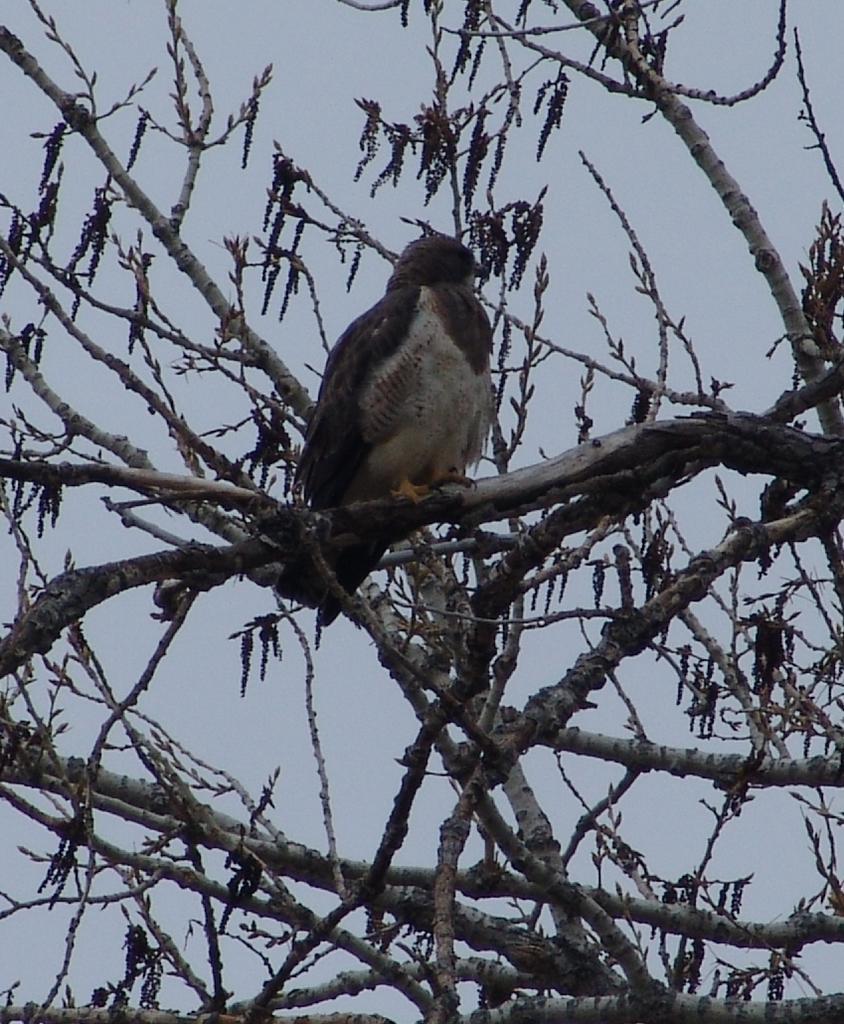Can you describe this image briefly? In this image we can see the bird, dried tree and the sky. 